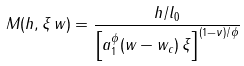Convert formula to latex. <formula><loc_0><loc_0><loc_500><loc_500>M ( h , \xi \, w ) = \frac { h / l _ { 0 } } { \left [ a _ { 1 } ^ { \phi } ( w - w _ { c } ) \, \xi \right ] ^ { ( 1 - \nu ) / \phi } }</formula> 